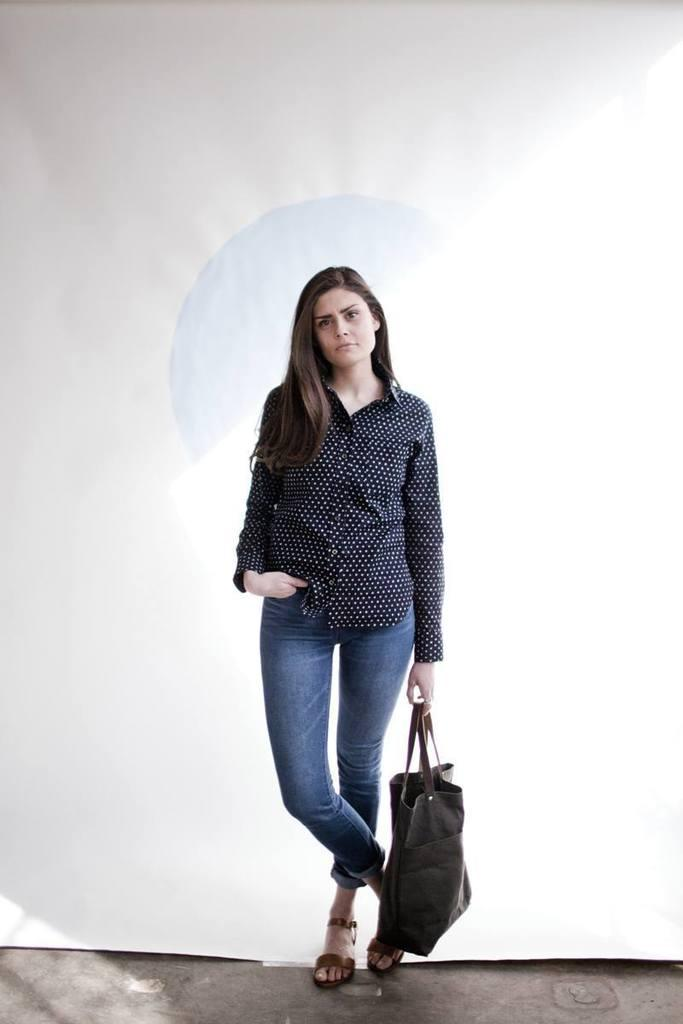Who is the main subject in the image? There is a woman in the image. Can you describe the woman's skin tone? The woman has a fair white skin tone. What is the woman wearing? The woman is wearing a black and white shirt and blue jeans. What is the woman doing in the image? The woman is standing and holding a bag. What can be seen in the background of the image? There is a white background in the image. What type of berry is the woman eating in the image? There is no berry present in the image, and the woman is not eating anything. 